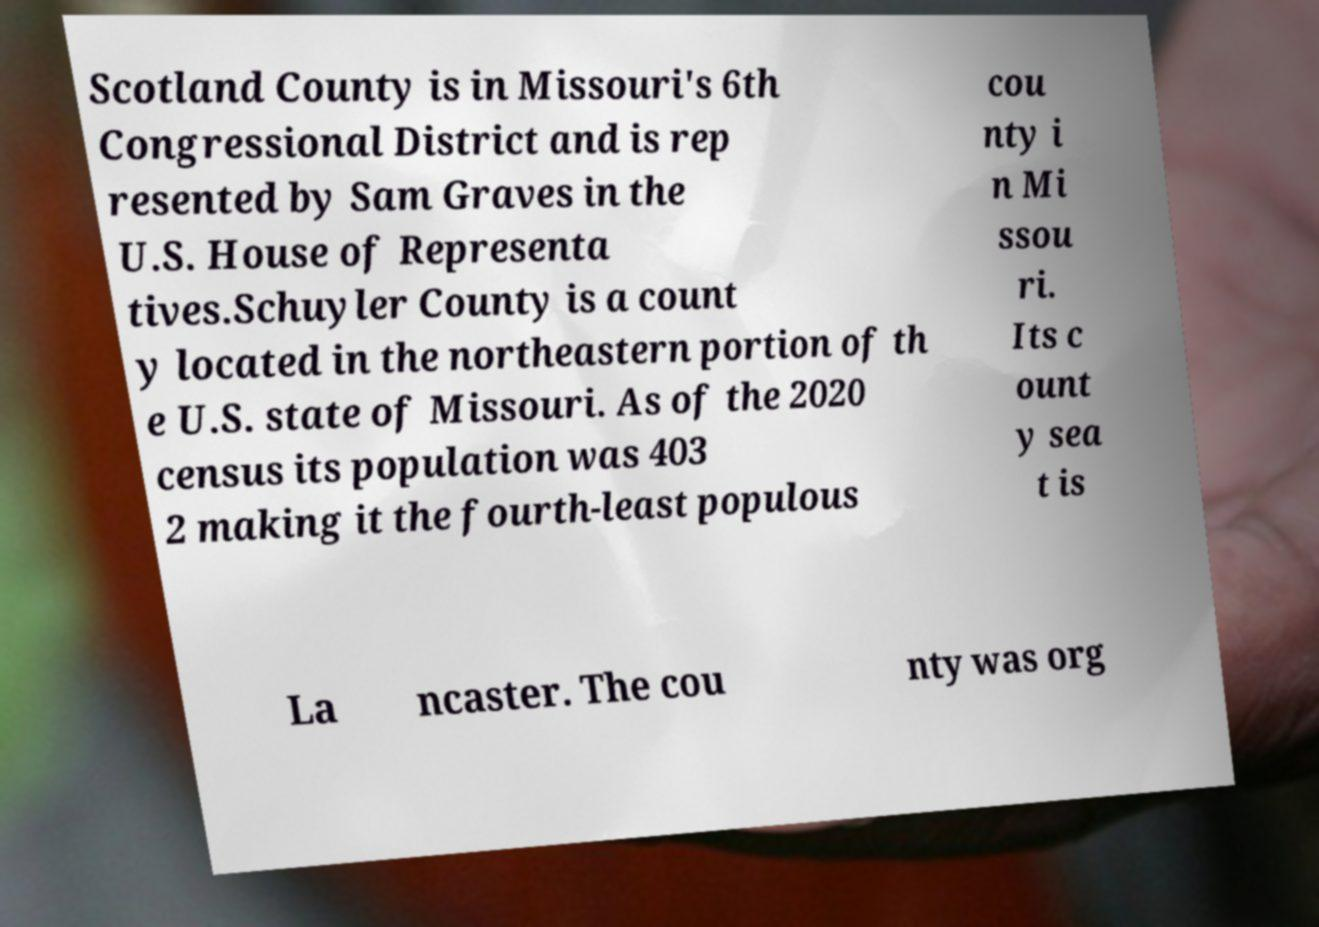Could you assist in decoding the text presented in this image and type it out clearly? Scotland County is in Missouri's 6th Congressional District and is rep resented by Sam Graves in the U.S. House of Representa tives.Schuyler County is a count y located in the northeastern portion of th e U.S. state of Missouri. As of the 2020 census its population was 403 2 making it the fourth-least populous cou nty i n Mi ssou ri. Its c ount y sea t is La ncaster. The cou nty was org 